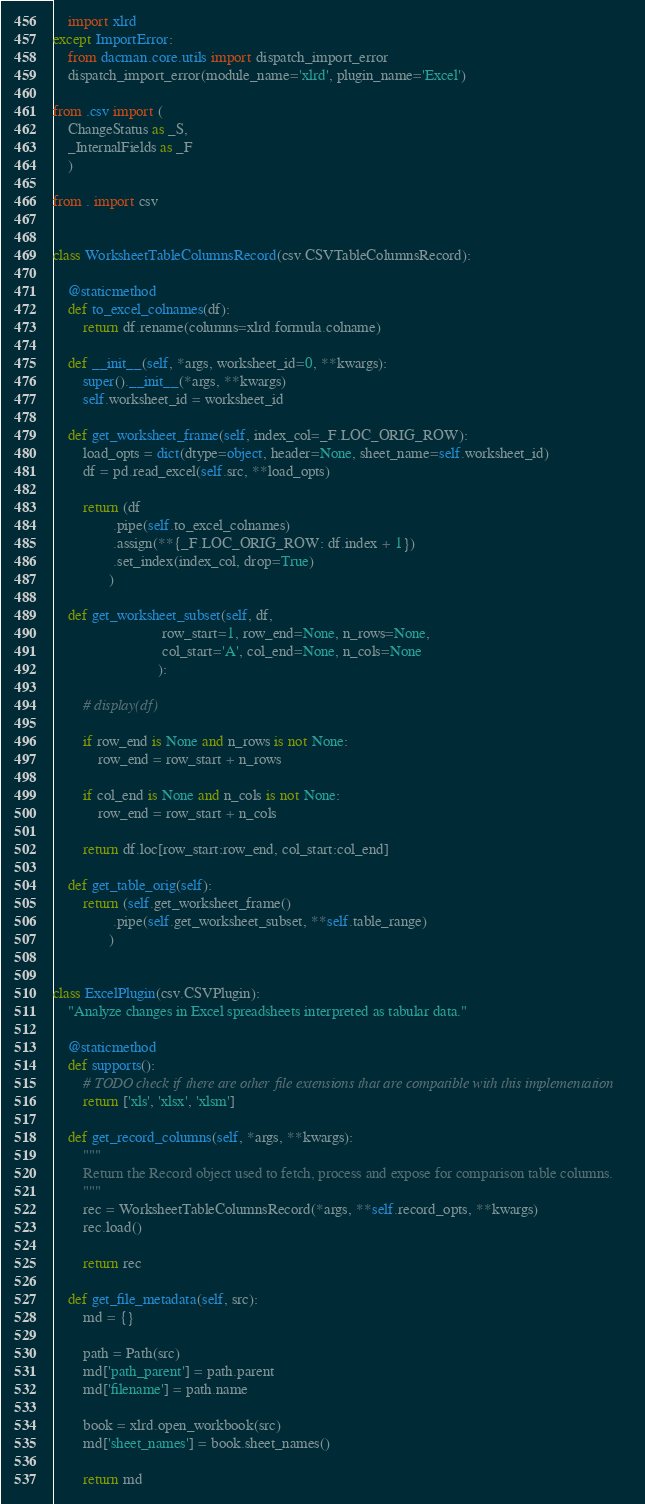<code> <loc_0><loc_0><loc_500><loc_500><_Python_>    import xlrd
except ImportError:
    from dacman.core.utils import dispatch_import_error
    dispatch_import_error(module_name='xlrd', plugin_name='Excel')

from .csv import (
    ChangeStatus as _S,
    _InternalFields as _F
    )

from . import csv


class WorksheetTableColumnsRecord(csv.CSVTableColumnsRecord):

    @staticmethod
    def to_excel_colnames(df):
        return df.rename(columns=xlrd.formula.colname)

    def __init__(self, *args, worksheet_id=0, **kwargs):
        super().__init__(*args, **kwargs)
        self.worksheet_id = worksheet_id

    def get_worksheet_frame(self, index_col=_F.LOC_ORIG_ROW):
        load_opts = dict(dtype=object, header=None, sheet_name=self.worksheet_id)
        df = pd.read_excel(self.src, **load_opts)

        return (df
                .pipe(self.to_excel_colnames)
                .assign(**{_F.LOC_ORIG_ROW: df.index + 1})
                .set_index(index_col, drop=True)
               )

    def get_worksheet_subset(self, df,
                             row_start=1, row_end=None, n_rows=None,
                             col_start='A', col_end=None, n_cols=None
                            ):

        # display(df)

        if row_end is None and n_rows is not None:
            row_end = row_start + n_rows

        if col_end is None and n_cols is not None:
            row_end = row_start + n_cols

        return df.loc[row_start:row_end, col_start:col_end]

    def get_table_orig(self):
        return (self.get_worksheet_frame()
                .pipe(self.get_worksheet_subset, **self.table_range)
               )


class ExcelPlugin(csv.CSVPlugin):
    "Analyze changes in Excel spreadsheets interpreted as tabular data."

    @staticmethod
    def supports():
        # TODO check if there are other file extensions that are compatible with this implementation
        return ['xls', 'xlsx', 'xlsm']

    def get_record_columns(self, *args, **kwargs):
        """
        Return the Record object used to fetch, process and expose for comparison table columns.
        """
        rec = WorksheetTableColumnsRecord(*args, **self.record_opts, **kwargs)
        rec.load()

        return rec

    def get_file_metadata(self, src):
        md = {}

        path = Path(src)
        md['path_parent'] = path.parent
        md['filename'] = path.name

        book = xlrd.open_workbook(src)
        md['sheet_names'] = book.sheet_names()

        return md
</code> 